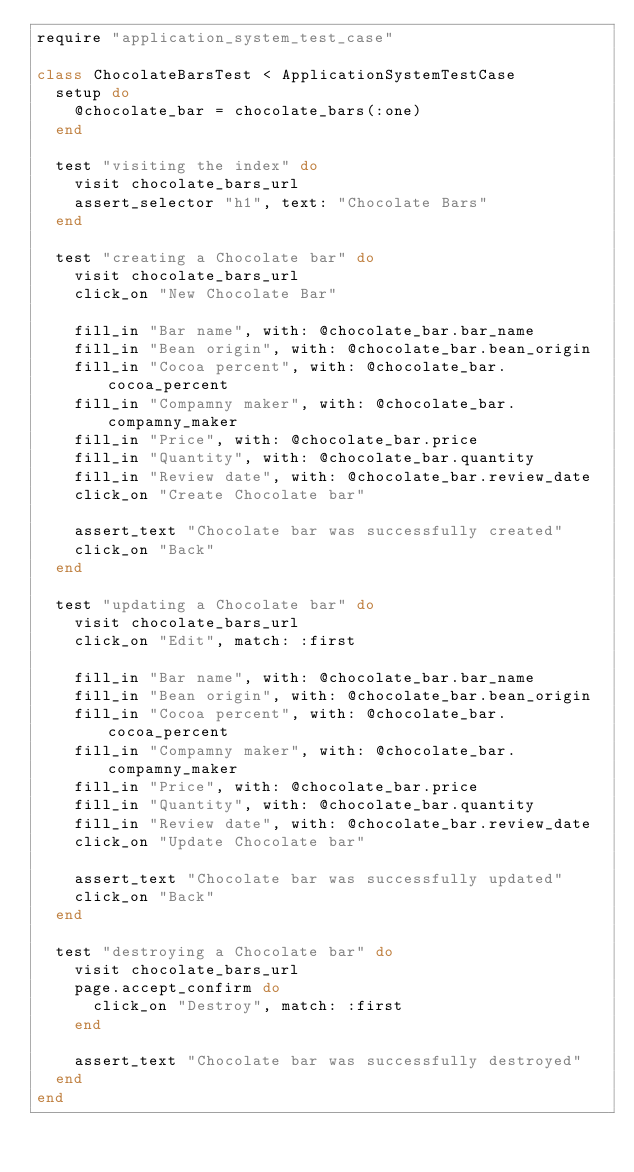<code> <loc_0><loc_0><loc_500><loc_500><_Ruby_>require "application_system_test_case"

class ChocolateBarsTest < ApplicationSystemTestCase
  setup do
    @chocolate_bar = chocolate_bars(:one)
  end

  test "visiting the index" do
    visit chocolate_bars_url
    assert_selector "h1", text: "Chocolate Bars"
  end

  test "creating a Chocolate bar" do
    visit chocolate_bars_url
    click_on "New Chocolate Bar"

    fill_in "Bar name", with: @chocolate_bar.bar_name
    fill_in "Bean origin", with: @chocolate_bar.bean_origin
    fill_in "Cocoa percent", with: @chocolate_bar.cocoa_percent
    fill_in "Compamny maker", with: @chocolate_bar.compamny_maker
    fill_in "Price", with: @chocolate_bar.price
    fill_in "Quantity", with: @chocolate_bar.quantity
    fill_in "Review date", with: @chocolate_bar.review_date
    click_on "Create Chocolate bar"

    assert_text "Chocolate bar was successfully created"
    click_on "Back"
  end

  test "updating a Chocolate bar" do
    visit chocolate_bars_url
    click_on "Edit", match: :first

    fill_in "Bar name", with: @chocolate_bar.bar_name
    fill_in "Bean origin", with: @chocolate_bar.bean_origin
    fill_in "Cocoa percent", with: @chocolate_bar.cocoa_percent
    fill_in "Compamny maker", with: @chocolate_bar.compamny_maker
    fill_in "Price", with: @chocolate_bar.price
    fill_in "Quantity", with: @chocolate_bar.quantity
    fill_in "Review date", with: @chocolate_bar.review_date
    click_on "Update Chocolate bar"

    assert_text "Chocolate bar was successfully updated"
    click_on "Back"
  end

  test "destroying a Chocolate bar" do
    visit chocolate_bars_url
    page.accept_confirm do
      click_on "Destroy", match: :first
    end

    assert_text "Chocolate bar was successfully destroyed"
  end
end
</code> 